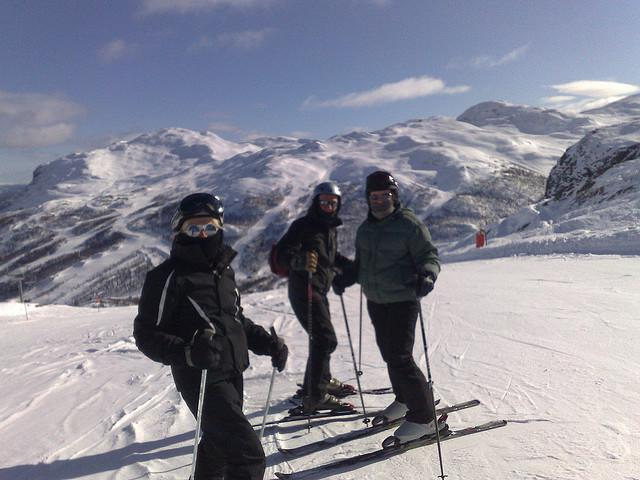Why are these people covering their faces?

Choices:
A) keeping warm
B) stopping covid
C) for style
D) as punishment keeping warm 